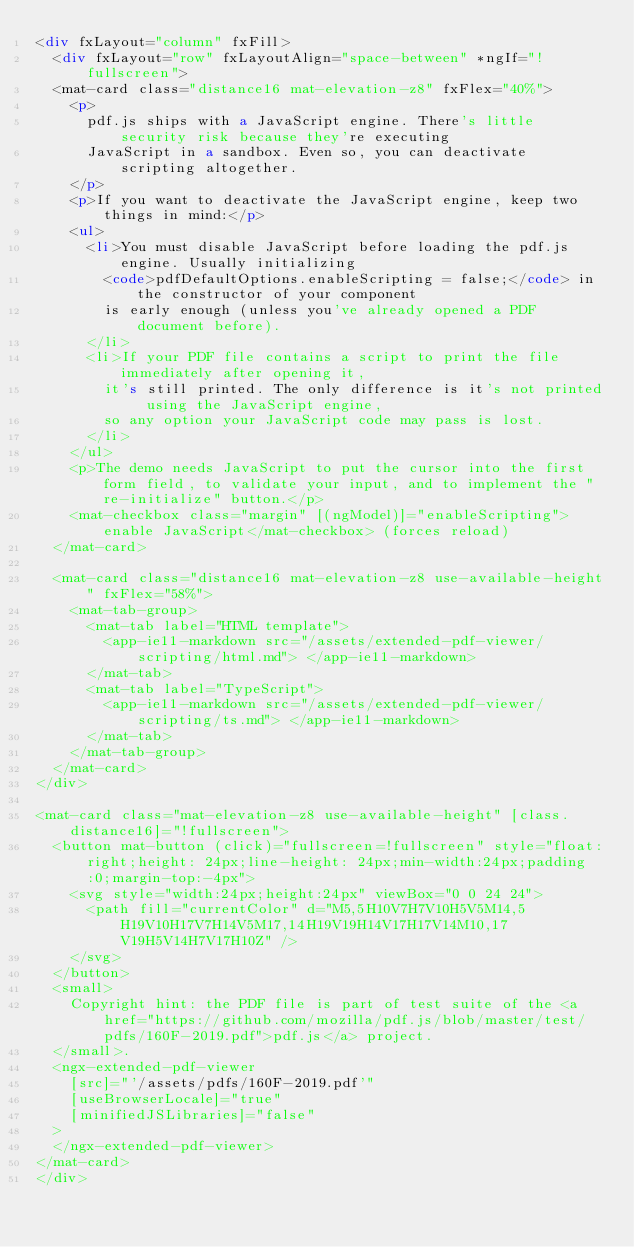<code> <loc_0><loc_0><loc_500><loc_500><_HTML_><div fxLayout="column" fxFill>
  <div fxLayout="row" fxLayoutAlign="space-between" *ngIf="!fullscreen">
  <mat-card class="distance16 mat-elevation-z8" fxFlex="40%">
    <p>
      pdf.js ships with a JavaScript engine. There's little security risk because they're executing
      JavaScript in a sandbox. Even so, you can deactivate scripting altogether.
    </p>
    <p>If you want to deactivate the JavaScript engine, keep two things in mind:</p>
    <ul>
      <li>You must disable JavaScript before loading the pdf.js engine. Usually initializing
        <code>pdfDefaultOptions.enableScripting = false;</code> in the constructor of your component
        is early enough (unless you've already opened a PDF document before).
      </li>
      <li>If your PDF file contains a script to print the file immediately after opening it,
        it's still printed. The only difference is it's not printed using the JavaScript engine,
        so any option your JavaScript code may pass is lost.
      </li>
    </ul>
    <p>The demo needs JavaScript to put the cursor into the first form field, to validate your input, and to implement the "re-initialize" button.</p>
    <mat-checkbox class="margin" [(ngModel)]="enableScripting">enable JavaScript</mat-checkbox> (forces reload)
  </mat-card>

  <mat-card class="distance16 mat-elevation-z8 use-available-height" fxFlex="58%">
    <mat-tab-group>
      <mat-tab label="HTML template">
        <app-ie11-markdown src="/assets/extended-pdf-viewer/scripting/html.md"> </app-ie11-markdown>
      </mat-tab>
      <mat-tab label="TypeScript">
        <app-ie11-markdown src="/assets/extended-pdf-viewer/scripting/ts.md"> </app-ie11-markdown>
      </mat-tab>
    </mat-tab-group>
  </mat-card>
</div>

<mat-card class="mat-elevation-z8 use-available-height" [class.distance16]="!fullscreen">
  <button mat-button (click)="fullscreen=!fullscreen" style="float:right;height: 24px;line-height: 24px;min-width:24px;padding:0;margin-top:-4px">
    <svg style="width:24px;height:24px" viewBox="0 0 24 24">
      <path fill="currentColor" d="M5,5H10V7H7V10H5V5M14,5H19V10H17V7H14V5M17,14H19V19H14V17H17V14M10,17V19H5V14H7V17H10Z" />
    </svg>
  </button>
  <small>
    Copyright hint: the PDF file is part of test suite of the <a href="https://github.com/mozilla/pdf.js/blob/master/test/pdfs/160F-2019.pdf">pdf.js</a> project.
  </small>.
  <ngx-extended-pdf-viewer
    [src]="'/assets/pdfs/160F-2019.pdf'"
    [useBrowserLocale]="true"
    [minifiedJSLibraries]="false"
  >
  </ngx-extended-pdf-viewer>
</mat-card>
</div>
</code> 